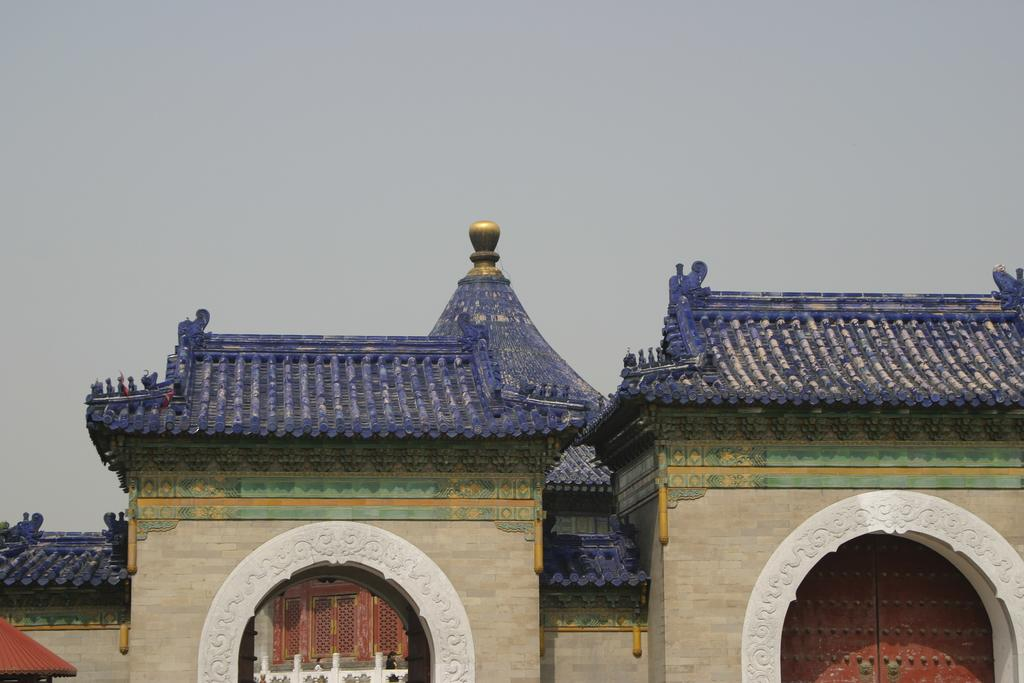What color are the roofs of some of the buildings in the image? The roofs of some buildings in the image are violet. Can you describe the roof of the building on the left side of the image? The roof of the building on the left side of the image is red. What can be seen in the background of the image? The sky is visible in the background of the image. How many legs does the horse have in the image? There is no horse present in the image. What is the weight of the object on the roof of the building with the red roof? There is no object on the roof of the building with the red roof mentioned in the image. 